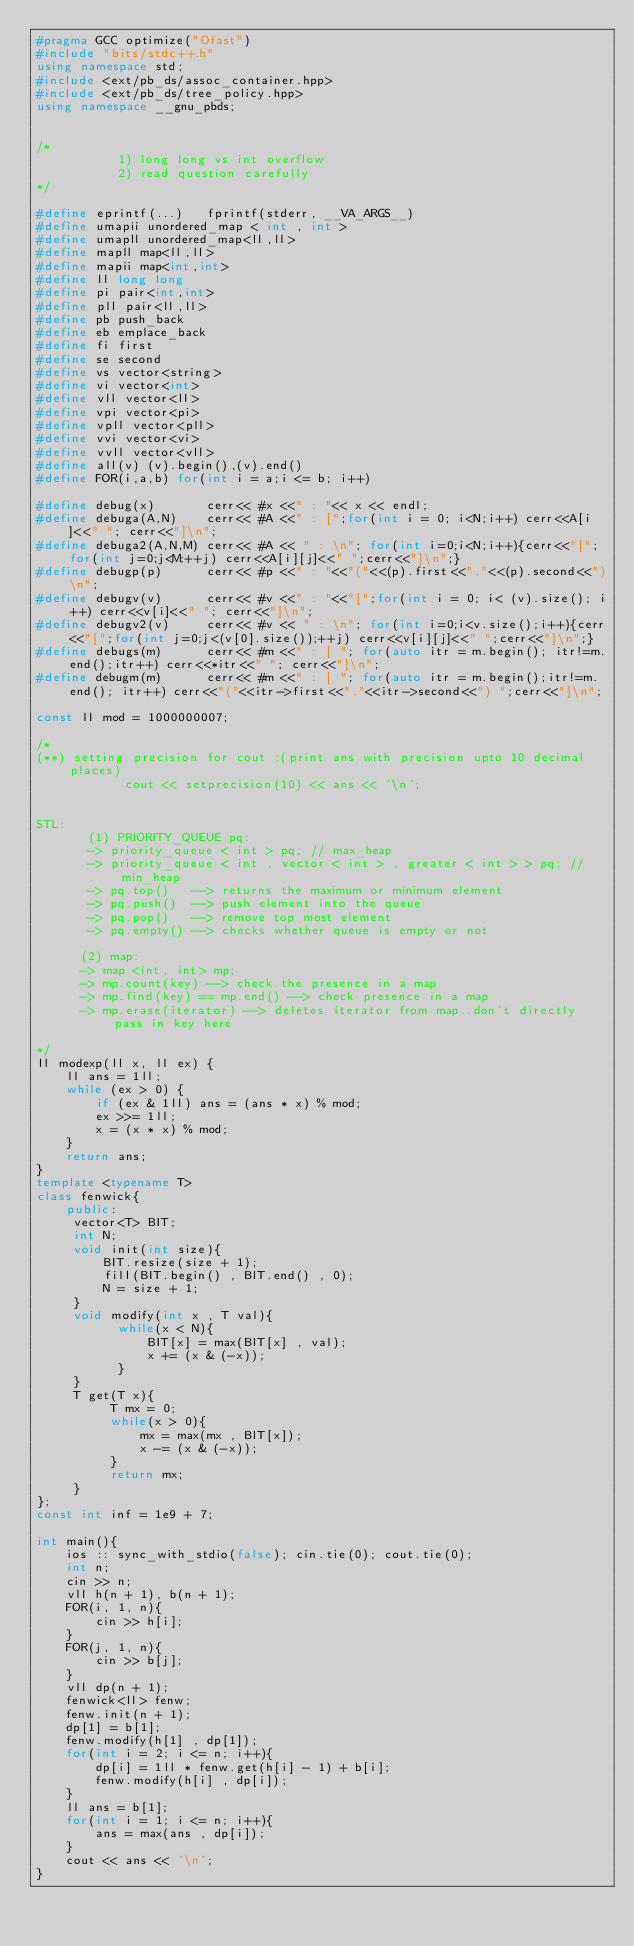<code> <loc_0><loc_0><loc_500><loc_500><_C++_>#pragma GCC optimize("Ofast")
#include "bits/stdc++.h"
using namespace std;
#include <ext/pb_ds/assoc_container.hpp>
#include <ext/pb_ds/tree_policy.hpp>
using namespace __gnu_pbds;


/*
           1) long long vs int overflow
           2) read question carefully
*/

#define eprintf(...)   fprintf(stderr, __VA_ARGS__)
#define umapii unordered_map < int , int >
#define umapll unordered_map<ll,ll>
#define mapll map<ll,ll>
#define mapii map<int,int>
#define ll long long
#define pi pair<int,int>
#define pll pair<ll,ll>
#define pb push_back
#define eb emplace_back
#define fi first
#define se second
#define vs vector<string>
#define vi vector<int>
#define vll vector<ll>
#define vpi vector<pi>
#define vpll vector<pll>
#define vvi vector<vi>
#define vvll vector<vll>
#define all(v) (v).begin(),(v).end()
#define FOR(i,a,b) for(int i = a;i <= b; i++)

#define debug(x)       cerr<< #x <<" : "<< x << endl;
#define debuga(A,N)    cerr<< #A <<" : [";for(int i = 0; i<N;i++) cerr<<A[i]<<" "; cerr<<"]\n";
#define debuga2(A,N,M) cerr<< #A << " : \n"; for(int i=0;i<N;i++){cerr<<"[";for(int j=0;j<M;++j) cerr<<A[i][j]<<" ";cerr<<"]\n";}
#define debugp(p)      cerr<< #p <<" : "<<"("<<(p).first<<","<<(p).second<<")\n";
#define debugv(v)      cerr<< #v <<" : "<<"[";for(int i = 0; i< (v).size(); i++) cerr<<v[i]<<" "; cerr<<"]\n";
#define debugv2(v)     cerr<< #v << " : \n"; for(int i=0;i<v.size();i++){cerr<<"[";for(int j=0;j<(v[0].size());++j) cerr<<v[i][j]<<" ";cerr<<"]\n";}
#define debugs(m)      cerr<< #m <<" : [ "; for(auto itr = m.begin(); itr!=m.end();itr++) cerr<<*itr<<" "; cerr<<"]\n";
#define debugm(m)      cerr<< #m <<" : [ "; for(auto itr = m.begin();itr!=m.end(); itr++) cerr<<"("<<itr->first<<","<<itr->second<<") ";cerr<<"]\n";

const ll mod = 1000000007;

/*
(**) setting precision for cout :(print ans with precision upto 10 decimal places) 
            cout << setprecision(10) << ans << '\n';


STL:
       (1) PRIORITY_QUEUE pq:
       -> priority_queue < int > pq; // max_heap
       -> priority_queue < int , vector < int > , greater < int > > pq; // min_heap 
       -> pq.top()   --> returns the maximum or minimum element
       -> pq.push()  --> push element into the queue
       -> pq.pop()   --> remove top most element
       -> pq.empty() --> checks whether queue is empty or not
     
      (2) map:
      -> map <int, int> mp;
      -> mp.count(key) --> check the presence in a map
      -> mp.find(key) == mp.end() --> check presence in a map
      -> mp.erase(iterator) --> deletes iterator from map..don't directly pass in key here

*/
ll modexp(ll x, ll ex) {
    ll ans = 1ll;
    while (ex > 0) {
        if (ex & 1ll) ans = (ans * x) % mod;
        ex >>= 1ll;
        x = (x * x) % mod;
    }
    return ans;
}
template <typename T>
class fenwick{
    public:
     vector<T> BIT;
     int N;
     void init(int size){ 
         BIT.resize(size + 1);
         fill(BIT.begin() , BIT.end() , 0);
         N = size + 1;
     }
     void modify(int x , T val){ 
           while(x < N){
               BIT[x] = max(BIT[x] , val);
               x += (x & (-x));
           }
     }
     T get(T x){
          T mx = 0;
          while(x > 0){
              mx = max(mx , BIT[x]);
              x -= (x & (-x));
          }
          return mx;
     }
};
const int inf = 1e9 + 7;

int main(){
    ios :: sync_with_stdio(false); cin.tie(0); cout.tie(0);
    int n;
    cin >> n;
    vll h(n + 1), b(n + 1);
    FOR(i, 1, n){
        cin >> h[i];
    }
    FOR(j, 1, n){
        cin >> b[j];
    }
    vll dp(n + 1);
    fenwick<ll> fenw;
    fenw.init(n + 1);  
    dp[1] = b[1];
    fenw.modify(h[1] , dp[1]);
    for(int i = 2; i <= n; i++){
        dp[i] = 1ll * fenw.get(h[i] - 1) + b[i];
        fenw.modify(h[i] , dp[i]);
    }
    ll ans = b[1];
    for(int i = 1; i <= n; i++){
        ans = max(ans , dp[i]);
    }
    cout << ans << '\n';
}</code> 